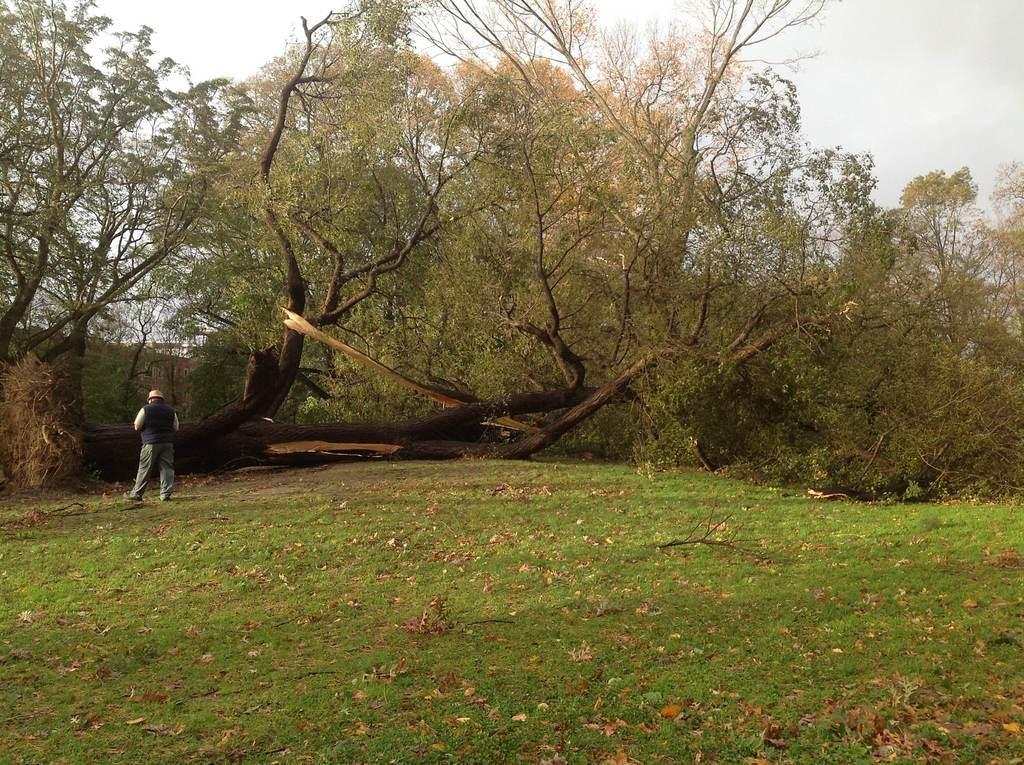Can you describe this image briefly? In the picture i can see a person standing in open area, there is lawn and in the background of the picture there are some trees, clear sky. 